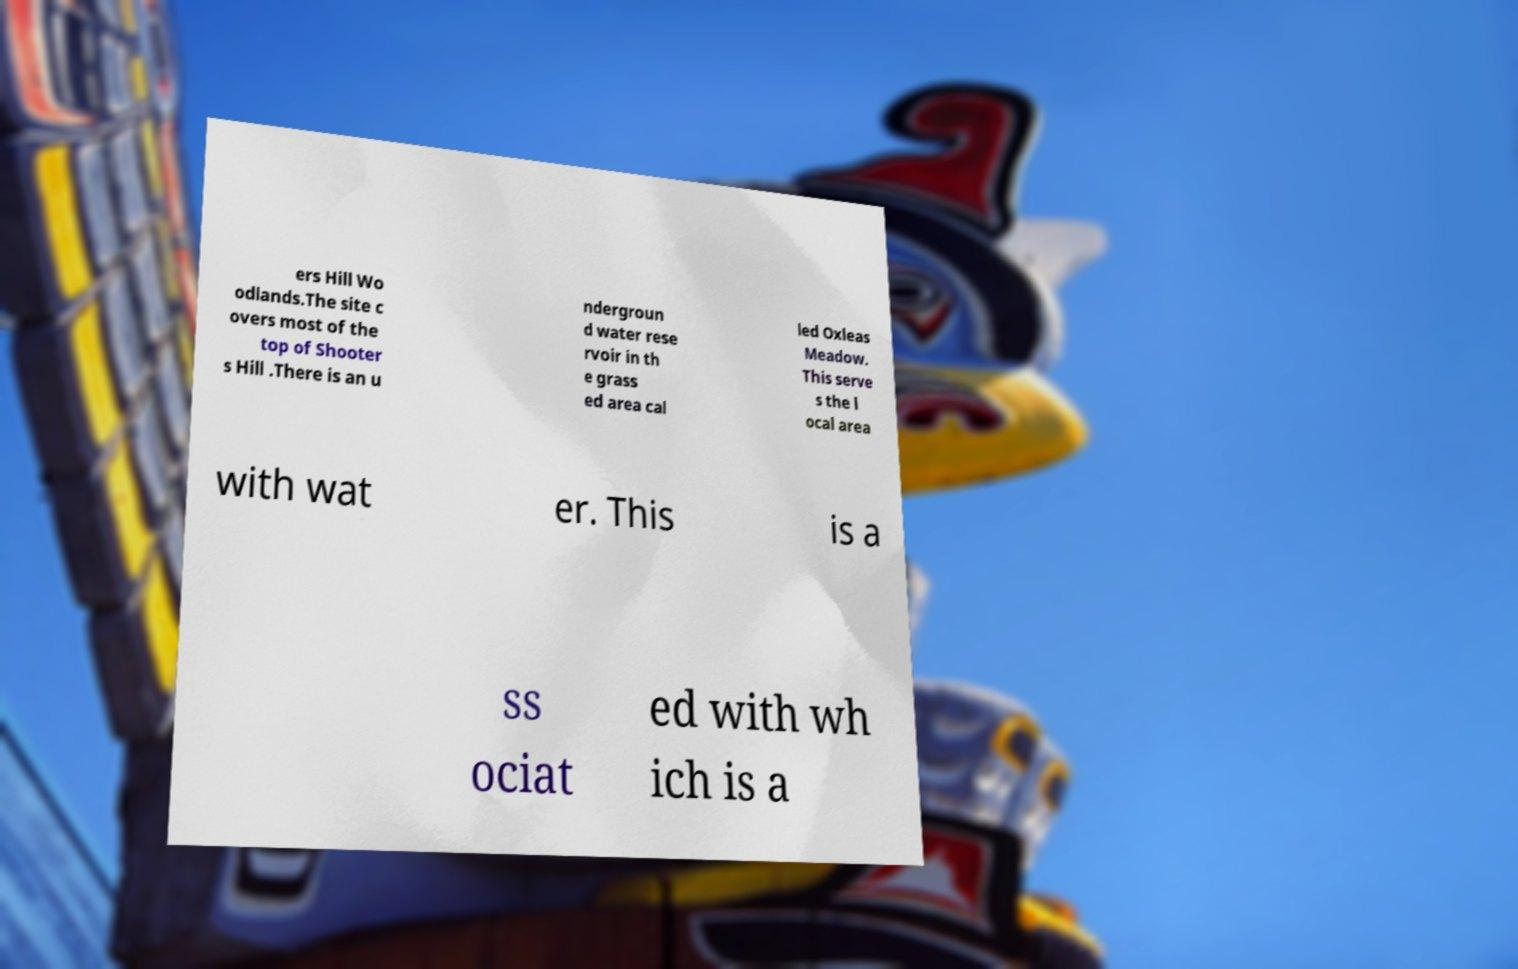Please identify and transcribe the text found in this image. ers Hill Wo odlands.The site c overs most of the top of Shooter s Hill .There is an u ndergroun d water rese rvoir in th e grass ed area cal led Oxleas Meadow. This serve s the l ocal area with wat er. This is a ss ociat ed with wh ich is a 